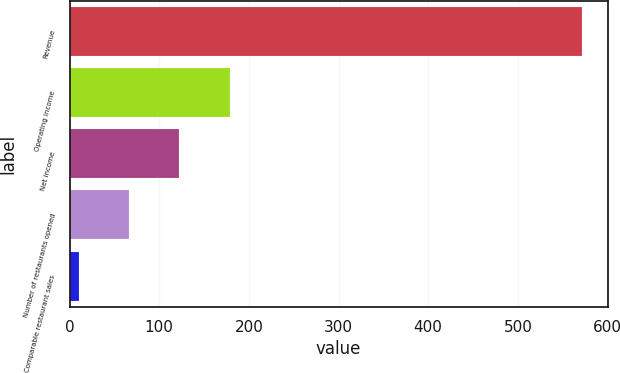<chart> <loc_0><loc_0><loc_500><loc_500><bar_chart><fcel>Revenue<fcel>Operating income<fcel>Net income<fcel>Number of restaurants opened<fcel>Comparable restaurant sales<nl><fcel>571.6<fcel>178.48<fcel>122.32<fcel>66.16<fcel>10<nl></chart> 